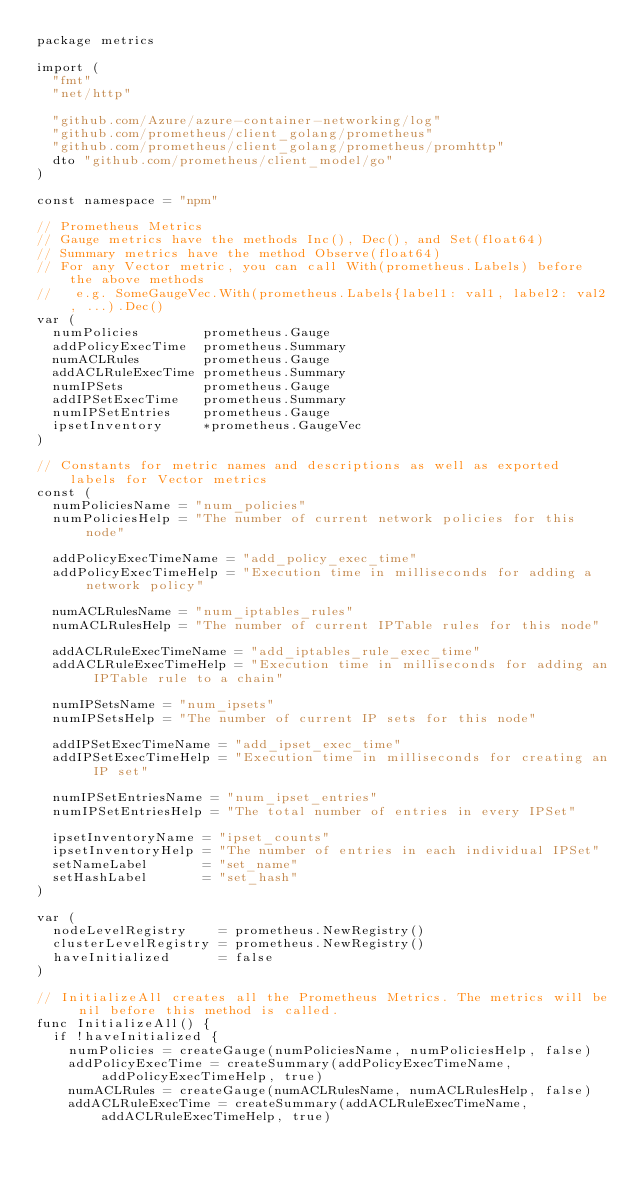<code> <loc_0><loc_0><loc_500><loc_500><_Go_>package metrics

import (
	"fmt"
	"net/http"

	"github.com/Azure/azure-container-networking/log"
	"github.com/prometheus/client_golang/prometheus"
	"github.com/prometheus/client_golang/prometheus/promhttp"
	dto "github.com/prometheus/client_model/go"
)

const namespace = "npm"

// Prometheus Metrics
// Gauge metrics have the methods Inc(), Dec(), and Set(float64)
// Summary metrics have the method Observe(float64)
// For any Vector metric, you can call With(prometheus.Labels) before the above methods
//   e.g. SomeGaugeVec.With(prometheus.Labels{label1: val1, label2: val2, ...).Dec()
var (
	numPolicies        prometheus.Gauge
	addPolicyExecTime  prometheus.Summary
	numACLRules        prometheus.Gauge
	addACLRuleExecTime prometheus.Summary
	numIPSets          prometheus.Gauge
	addIPSetExecTime   prometheus.Summary
	numIPSetEntries    prometheus.Gauge
	ipsetInventory     *prometheus.GaugeVec
)

// Constants for metric names and descriptions as well as exported labels for Vector metrics
const (
	numPoliciesName = "num_policies"
	numPoliciesHelp = "The number of current network policies for this node"

	addPolicyExecTimeName = "add_policy_exec_time"
	addPolicyExecTimeHelp = "Execution time in milliseconds for adding a network policy"

	numACLRulesName = "num_iptables_rules"
	numACLRulesHelp = "The number of current IPTable rules for this node"

	addACLRuleExecTimeName = "add_iptables_rule_exec_time"
	addACLRuleExecTimeHelp = "Execution time in milliseconds for adding an IPTable rule to a chain"

	numIPSetsName = "num_ipsets"
	numIPSetsHelp = "The number of current IP sets for this node"

	addIPSetExecTimeName = "add_ipset_exec_time"
	addIPSetExecTimeHelp = "Execution time in milliseconds for creating an IP set"

	numIPSetEntriesName = "num_ipset_entries"
	numIPSetEntriesHelp = "The total number of entries in every IPSet"

	ipsetInventoryName = "ipset_counts"
	ipsetInventoryHelp = "The number of entries in each individual IPSet"
	setNameLabel       = "set_name"
	setHashLabel       = "set_hash"
)

var (
	nodeLevelRegistry    = prometheus.NewRegistry()
	clusterLevelRegistry = prometheus.NewRegistry()
	haveInitialized      = false
)

// InitializeAll creates all the Prometheus Metrics. The metrics will be nil before this method is called.
func InitializeAll() {
	if !haveInitialized {
		numPolicies = createGauge(numPoliciesName, numPoliciesHelp, false)
		addPolicyExecTime = createSummary(addPolicyExecTimeName, addPolicyExecTimeHelp, true)
		numACLRules = createGauge(numACLRulesName, numACLRulesHelp, false)
		addACLRuleExecTime = createSummary(addACLRuleExecTimeName, addACLRuleExecTimeHelp, true)</code> 